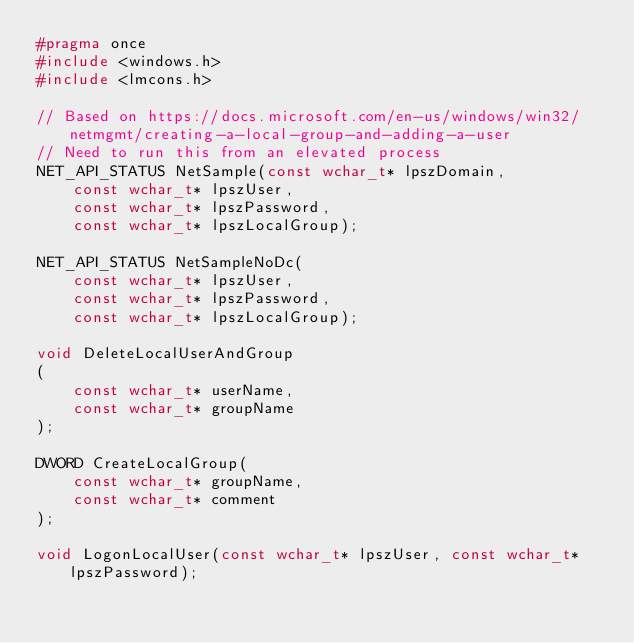<code> <loc_0><loc_0><loc_500><loc_500><_C++_>#pragma once
#include <windows.h>
#include <lmcons.h>

// Based on https://docs.microsoft.com/en-us/windows/win32/netmgmt/creating-a-local-group-and-adding-a-user
// Need to run this from an elevated process
NET_API_STATUS NetSample(const wchar_t* lpszDomain,
    const wchar_t* lpszUser,
    const wchar_t* lpszPassword,
    const wchar_t* lpszLocalGroup);

NET_API_STATUS NetSampleNoDc(
    const wchar_t* lpszUser,
    const wchar_t* lpszPassword,
    const wchar_t* lpszLocalGroup);

void DeleteLocalUserAndGroup
(
    const wchar_t* userName,
    const wchar_t* groupName
);

DWORD CreateLocalGroup(
    const wchar_t* groupName,
    const wchar_t* comment
);

void LogonLocalUser(const wchar_t* lpszUser, const wchar_t* lpszPassword);
</code> 